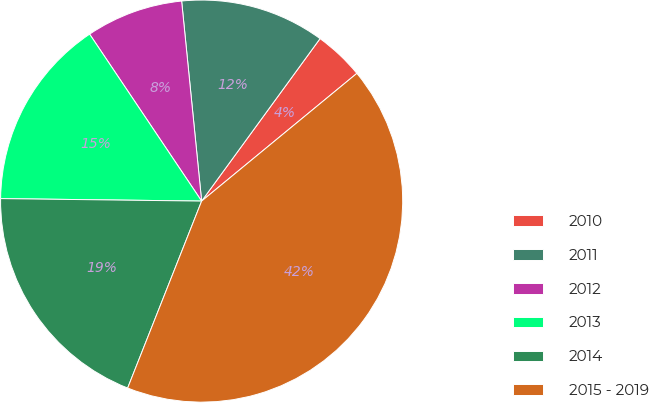Convert chart to OTSL. <chart><loc_0><loc_0><loc_500><loc_500><pie_chart><fcel>2010<fcel>2011<fcel>2012<fcel>2013<fcel>2014<fcel>2015 - 2019<nl><fcel>4.02%<fcel>11.61%<fcel>7.82%<fcel>15.4%<fcel>19.2%<fcel>41.96%<nl></chart> 